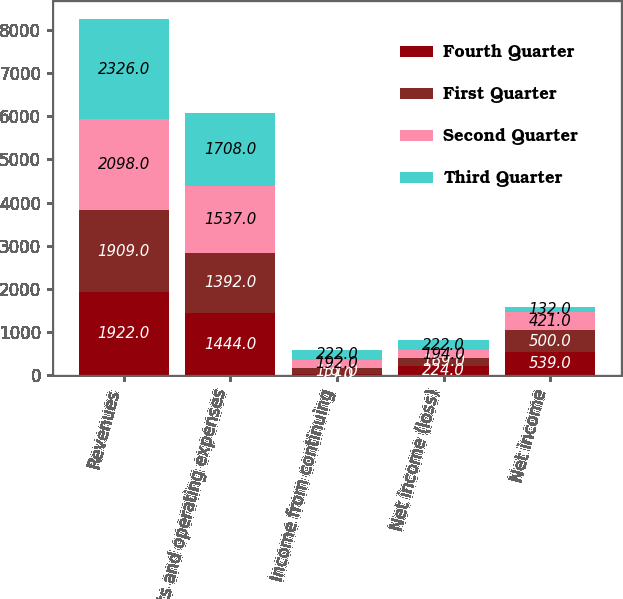Convert chart. <chart><loc_0><loc_0><loc_500><loc_500><stacked_bar_chart><ecel><fcel>Revenues<fcel>Costs and operating expenses<fcel>Income from continuing<fcel>Net income (loss)<fcel>Net income<nl><fcel>Fourth Quarter<fcel>1922<fcel>1444<fcel>19<fcel>224<fcel>539<nl><fcel>First Quarter<fcel>1909<fcel>1392<fcel>151<fcel>169<fcel>500<nl><fcel>Second Quarter<fcel>2098<fcel>1537<fcel>192<fcel>194<fcel>421<nl><fcel>Third Quarter<fcel>2326<fcel>1708<fcel>222<fcel>222<fcel>132<nl></chart> 